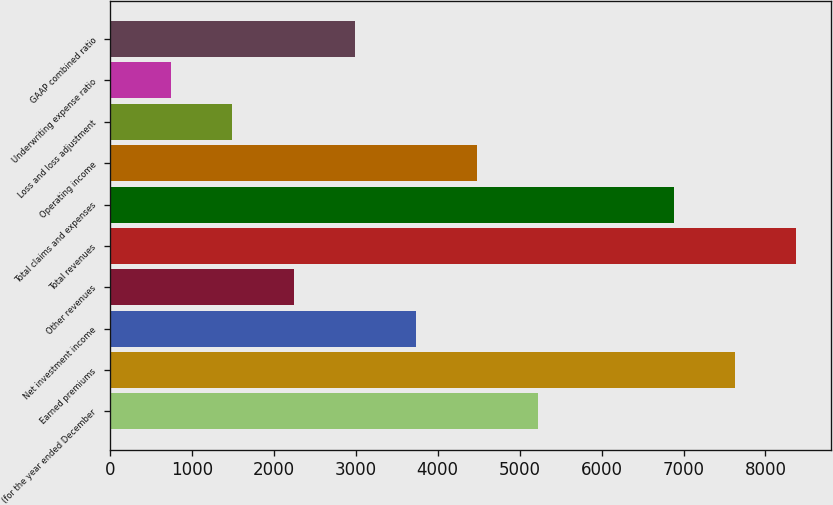Convert chart to OTSL. <chart><loc_0><loc_0><loc_500><loc_500><bar_chart><fcel>(for the year ended December<fcel>Earned premiums<fcel>Net investment income<fcel>Other revenues<fcel>Total revenues<fcel>Total claims and expenses<fcel>Operating income<fcel>Loss and loss adjustment<fcel>Underwriting expense ratio<fcel>GAAP combined ratio<nl><fcel>5226.35<fcel>7631.55<fcel>3733.25<fcel>2240.15<fcel>8378.1<fcel>6885<fcel>4479.8<fcel>1493.6<fcel>747.05<fcel>2986.7<nl></chart> 